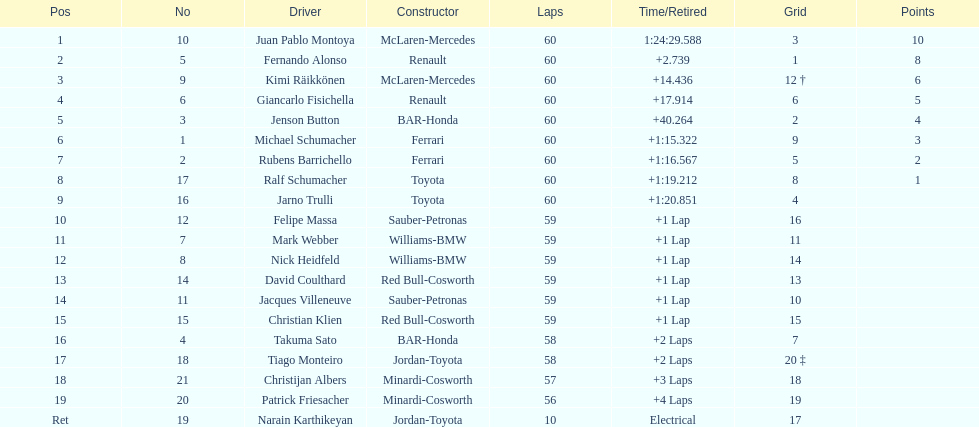Which driver came next after giancarlo fisichella? Jenson Button. 